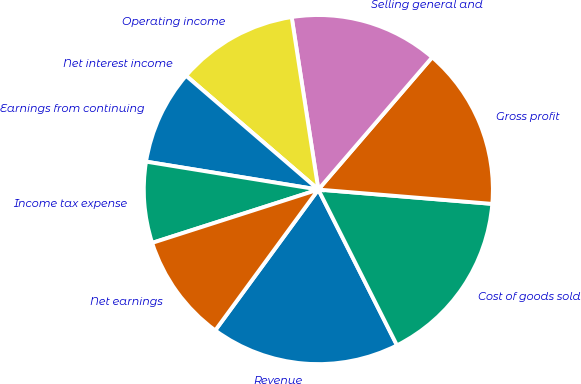Convert chart to OTSL. <chart><loc_0><loc_0><loc_500><loc_500><pie_chart><fcel>Revenue<fcel>Cost of goods sold<fcel>Gross profit<fcel>Selling general and<fcel>Operating income<fcel>Net interest income<fcel>Earnings from continuing<fcel>Income tax expense<fcel>Net earnings<nl><fcel>17.5%<fcel>16.25%<fcel>15.0%<fcel>13.75%<fcel>11.25%<fcel>0.0%<fcel>8.75%<fcel>7.5%<fcel>10.0%<nl></chart> 